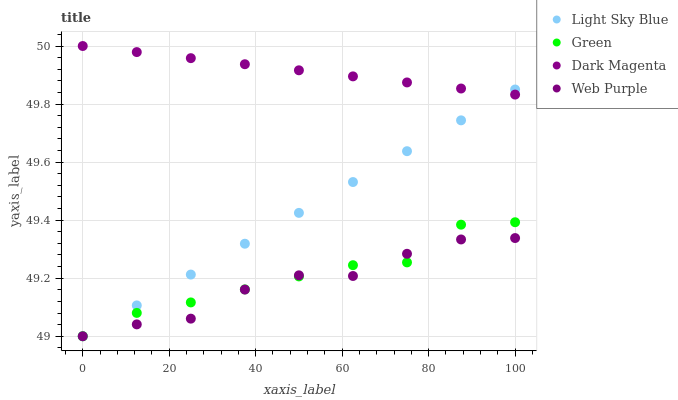Does Web Purple have the minimum area under the curve?
Answer yes or no. Yes. Does Dark Magenta have the maximum area under the curve?
Answer yes or no. Yes. Does Light Sky Blue have the minimum area under the curve?
Answer yes or no. No. Does Light Sky Blue have the maximum area under the curve?
Answer yes or no. No. Is Light Sky Blue the smoothest?
Answer yes or no. Yes. Is Web Purple the roughest?
Answer yes or no. Yes. Is Green the smoothest?
Answer yes or no. No. Is Green the roughest?
Answer yes or no. No. Does Web Purple have the lowest value?
Answer yes or no. Yes. Does Dark Magenta have the lowest value?
Answer yes or no. No. Does Dark Magenta have the highest value?
Answer yes or no. Yes. Does Light Sky Blue have the highest value?
Answer yes or no. No. Is Web Purple less than Dark Magenta?
Answer yes or no. Yes. Is Dark Magenta greater than Green?
Answer yes or no. Yes. Does Web Purple intersect Light Sky Blue?
Answer yes or no. Yes. Is Web Purple less than Light Sky Blue?
Answer yes or no. No. Is Web Purple greater than Light Sky Blue?
Answer yes or no. No. Does Web Purple intersect Dark Magenta?
Answer yes or no. No. 